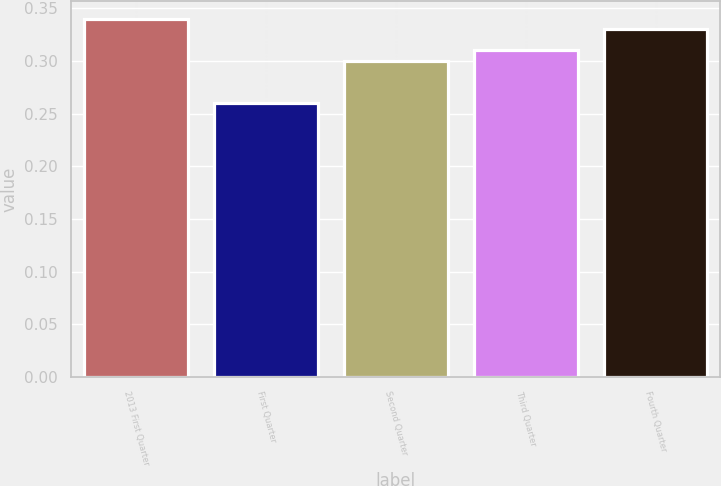Convert chart to OTSL. <chart><loc_0><loc_0><loc_500><loc_500><bar_chart><fcel>2013 First Quarter<fcel>First Quarter<fcel>Second Quarter<fcel>Third Quarter<fcel>Fourth Quarter<nl><fcel>0.34<fcel>0.26<fcel>0.3<fcel>0.31<fcel>0.33<nl></chart> 